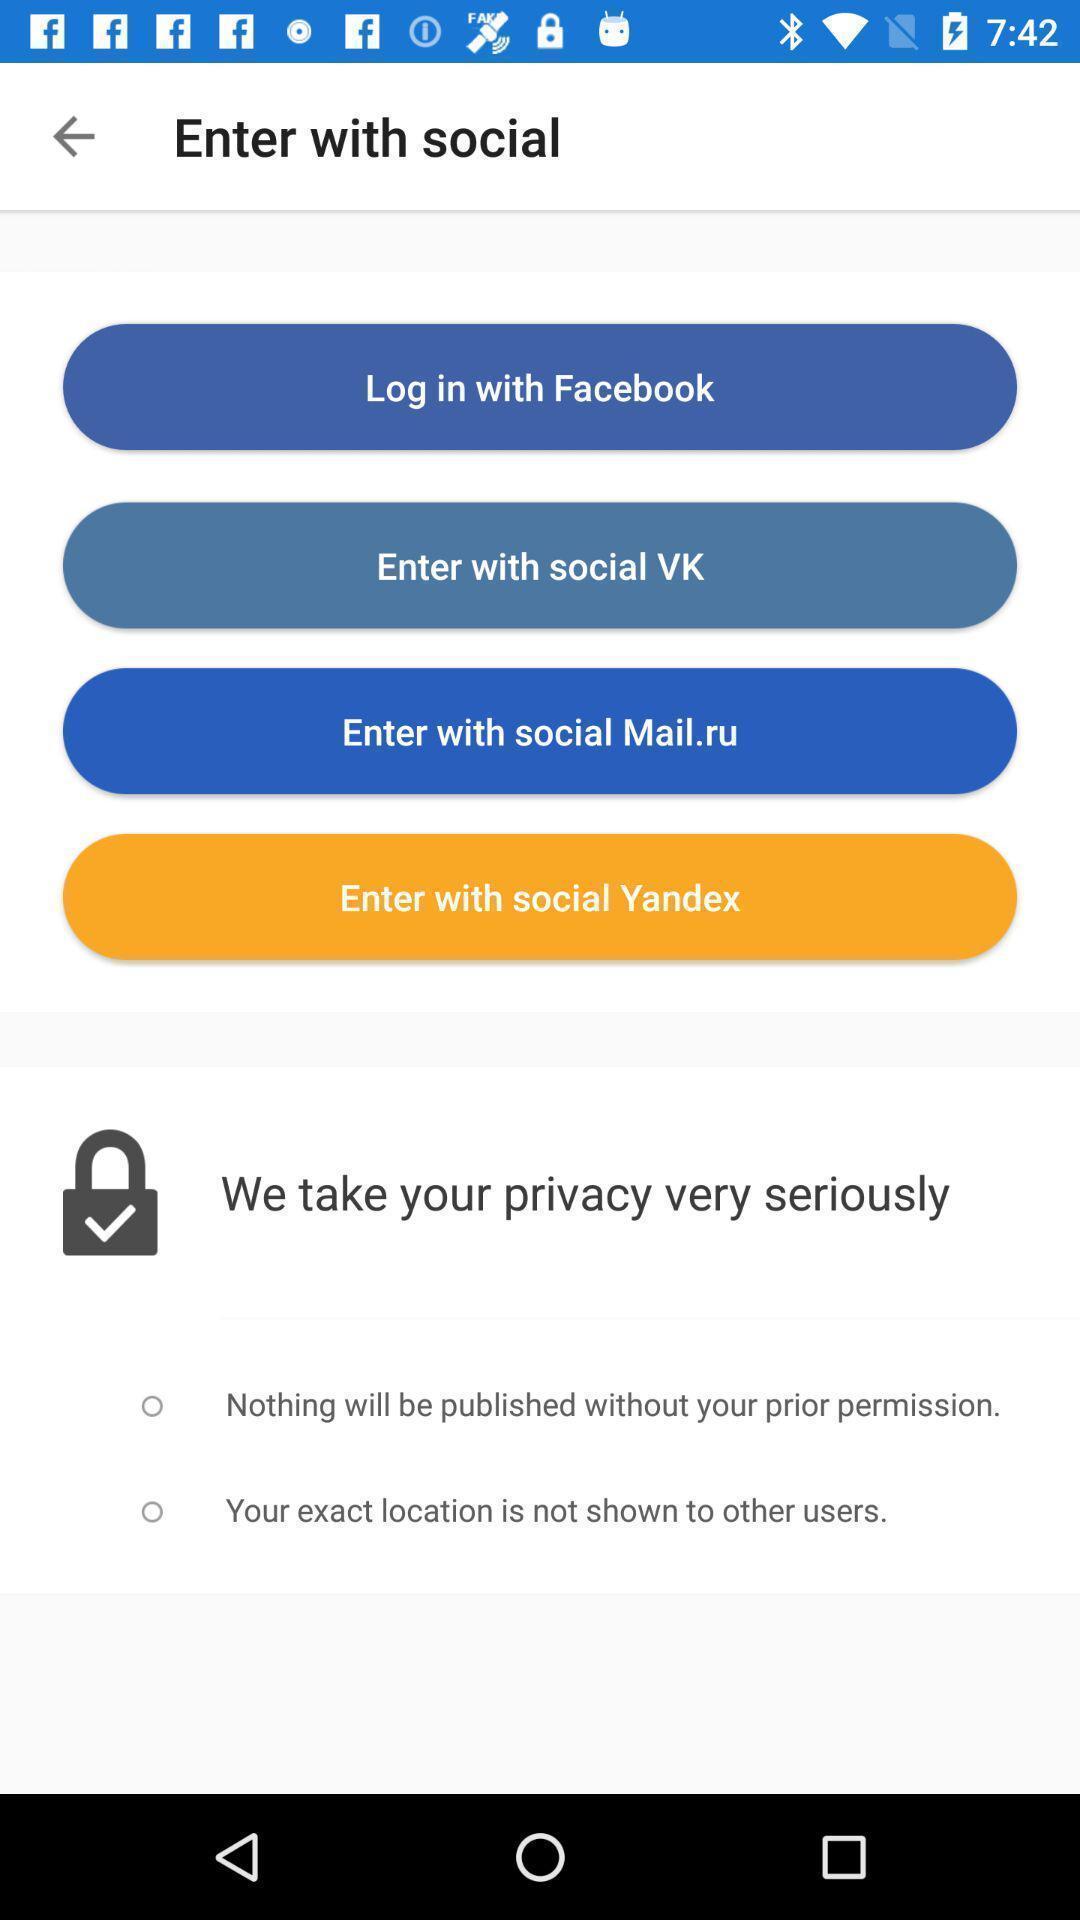Describe the key features of this screenshot. Screen displaying the login page. 